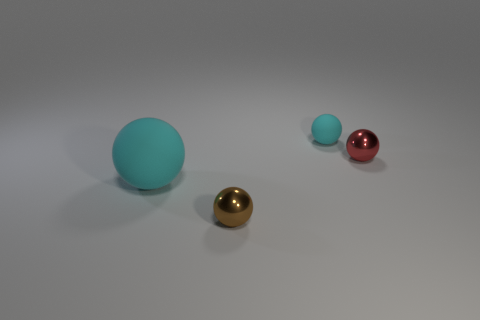Subtract all large cyan balls. How many balls are left? 3 Subtract all brown spheres. How many spheres are left? 3 Add 3 shiny spheres. How many objects exist? 7 Subtract 3 spheres. How many spheres are left? 1 Subtract all small objects. Subtract all small red objects. How many objects are left? 0 Add 3 red metallic spheres. How many red metallic spheres are left? 4 Add 3 blue rubber spheres. How many blue rubber spheres exist? 3 Subtract 0 green spheres. How many objects are left? 4 Subtract all purple balls. Subtract all green cylinders. How many balls are left? 4 Subtract all purple cylinders. How many cyan balls are left? 2 